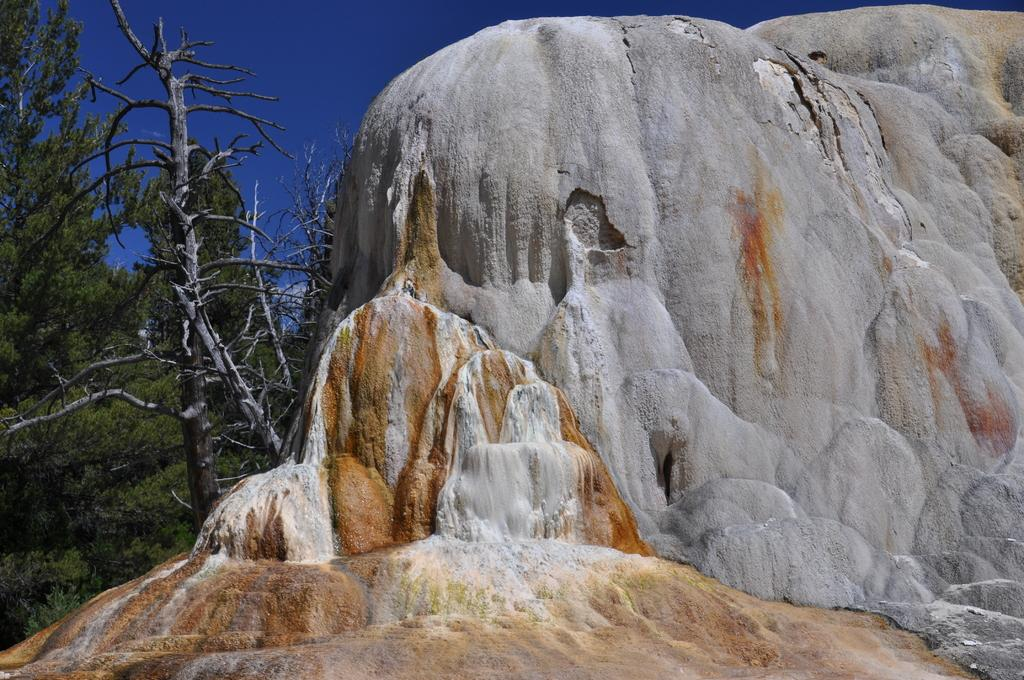What can be seen on the right side of the image? There is a rock on the right side of the image. What is located on the left side of the image? There are trees on the left side of the image. What is visible at the top of the image? The sky is visible at the top of the image. What is the purpose of the bit in the image? There is no bit present in the image, so it is not possible to determine its purpose. 